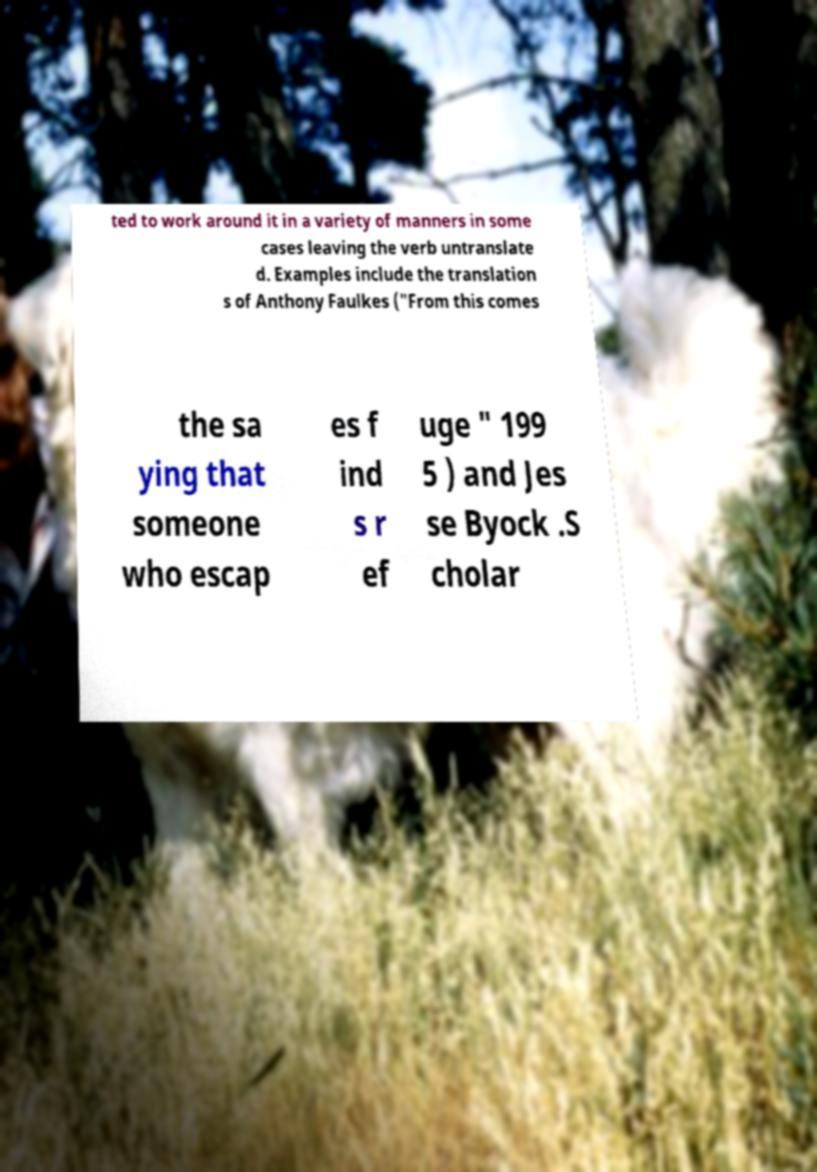There's text embedded in this image that I need extracted. Can you transcribe it verbatim? ted to work around it in a variety of manners in some cases leaving the verb untranslate d. Examples include the translation s of Anthony Faulkes ("From this comes the sa ying that someone who escap es f ind s r ef uge " 199 5 ) and Jes se Byock .S cholar 